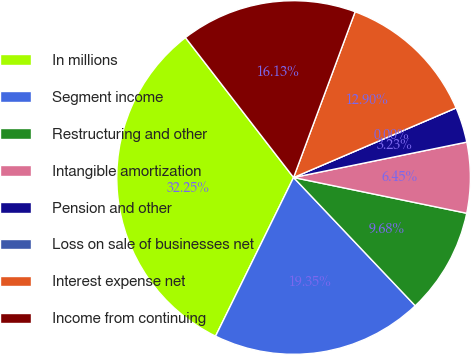Convert chart to OTSL. <chart><loc_0><loc_0><loc_500><loc_500><pie_chart><fcel>In millions<fcel>Segment income<fcel>Restructuring and other<fcel>Intangible amortization<fcel>Pension and other<fcel>Loss on sale of businesses net<fcel>Interest expense net<fcel>Income from continuing<nl><fcel>32.25%<fcel>19.35%<fcel>9.68%<fcel>6.45%<fcel>3.23%<fcel>0.0%<fcel>12.9%<fcel>16.13%<nl></chart> 